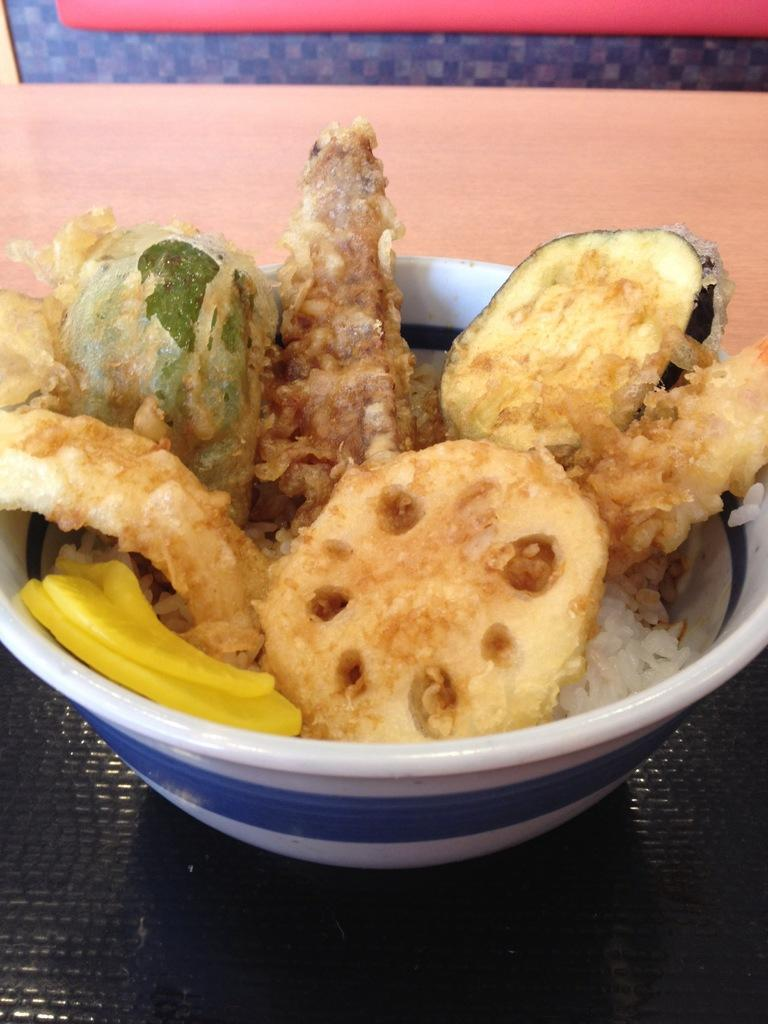What type of food item is in the bowl in the image? The specific type of food item is not mentioned, but there is a food item in a bowl in the image. Where is the bowl located in the image? The bowl is on a table in the image. Can you describe the background of the image? There is an object visible in the background of the image, but its description is not provided. What advice does the food item in the bowl give to the viewer in the image? The food item in the bowl does not give any advice to the viewer in the image, as it is an inanimate object. 